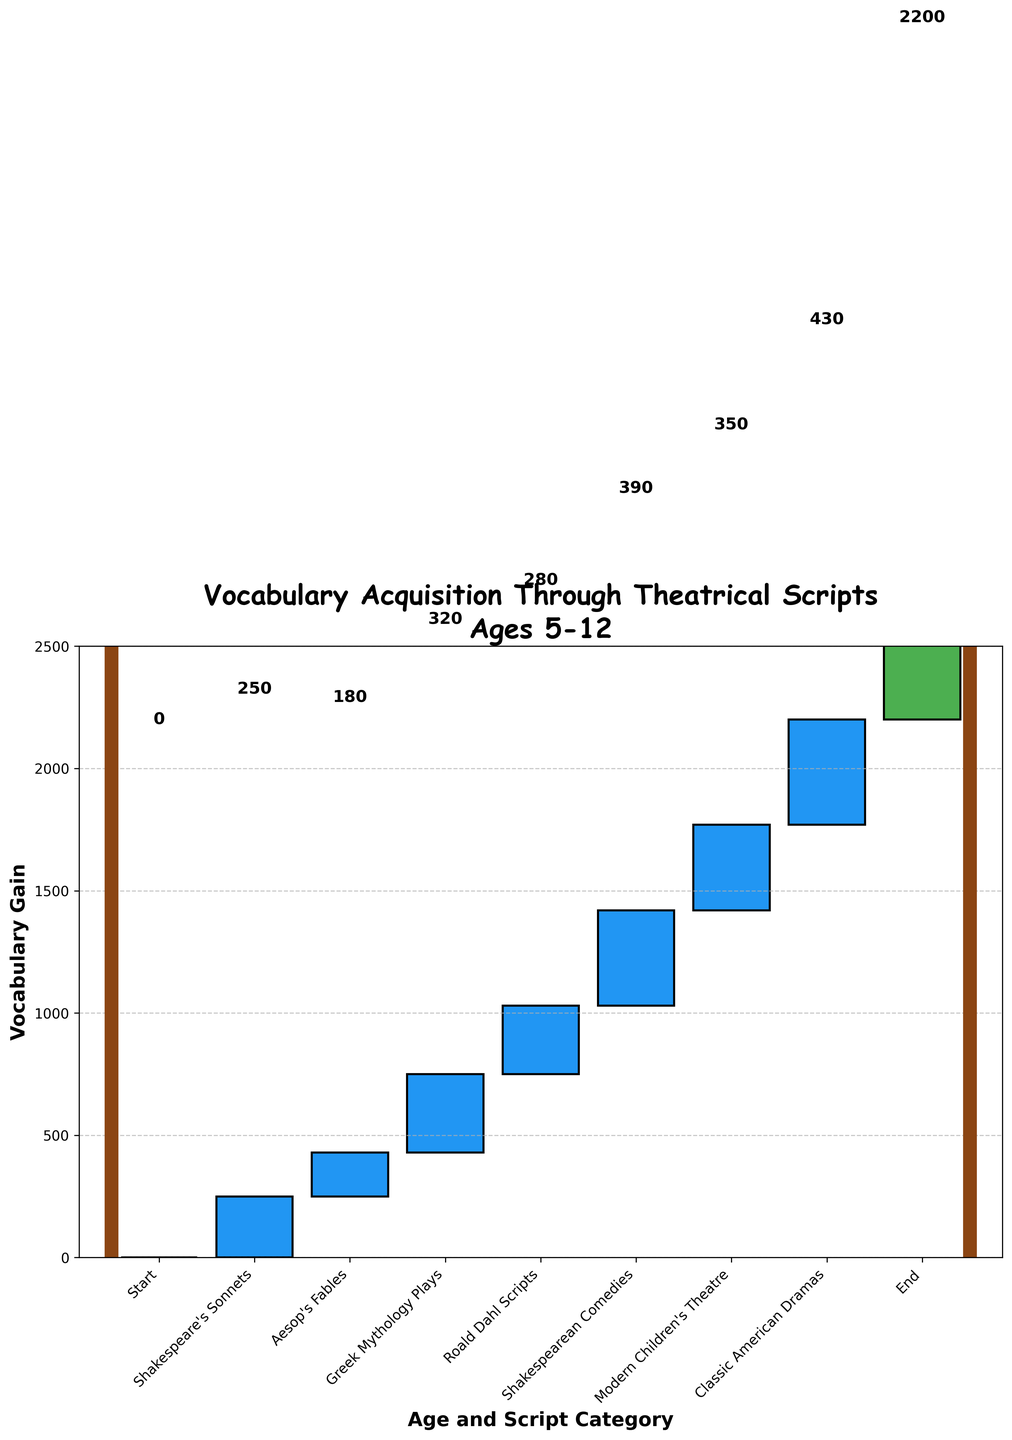What's the total vocabulary gain from ages 6 to 12? To determine the total vocabulary gain, sum the values from age 6 to age 12. This includes (250 + 180 + 320 + 280 + 390 + 350 + 430). Summing these values gives 2200.
Answer: 2200 Which age group shows the highest vocabulary gain? Check the vocabulary gain values for each age and identify the maximum value. Age 12 has the highest value at 430.
Answer: Age 12 What's the difference in vocabulary gain between the ages where Shakespeare's works are used? (Shakespeare's Sonnets vs. Shakespearean Comedies) Look at the gains for Shakespeare's Sonnets at age 6 (250) and Shakespearean Comedies at age 10 (390). Subtract 250 from 390 to get the difference, which is 140.
Answer: 140 Which theatrical script category contributed the least to vocabulary acquisition? Identify the category with the lowest vocabulary gain. Aesop's Fables at age 7 has the lowest value at 180.
Answer: Aesop's Fables What is the average vocabulary gain per year from ages 6 to 12? To calculate the average vocabulary gain, sum the annual gains: (250 + 180 + 320 + 280 + 390 + 350 + 430). The total is 2200. Divide by the number of years (7) to get an average gain of 314.29.
Answer: 314.29 How much more vocabulary is acquired through Greek Mythology Plays compared to Aesop's Fables? Find the values for Greek Mythology Plays (320) and Aesop's Fables (180). Subtract 180 from 320 to get the difference, which is 140.
Answer: 140 What is the cumulative vocabulary gain by age 10? Calculate the cumulative gain up to age 10: 0 (start) + 250 (age 6) + 180 (age 7) + 320 (age 8) + 280 (age 9) + 390 (age 10). The cumulative total is 1420.
Answer: 1420 How does the vocabulary gain from Modern Children's Theatre compare to Roald Dahl Scripts? Compare the vocabulary gains for Modern Children's Theatre (350) and Roald Dahl Scripts (280). Modern Children's Theatre has a gain of 70 more than Roald Dahl Scripts.
Answer: 70 What is the net change in vocabulary acquisition from age 6 to age 7? Compare the vocabulary gains between ages 6 (250) and 7 (180). The net change decrease is calculated as 250 - 180 = 70.
Answer: -70 By what percentage did vocabulary acquisition increase from age 9 (Roald Dahl Scripts) to age 10 (Shakespearean Comedies)? Calculate the gain for ages 9 (280) and 10 (390). The change is 390 - 280 = 110. The percentage increase is (110 / 280) * 100, which equals approximately 39.29%.
Answer: 39.29% 